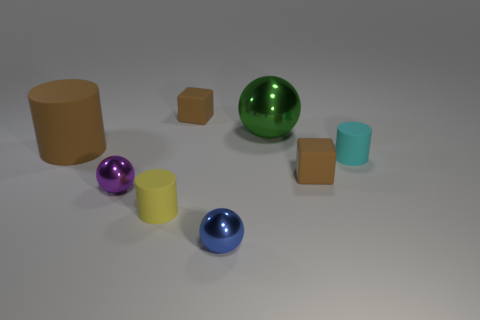Subtract all big green spheres. How many spheres are left? 2 Add 1 big blue shiny cylinders. How many objects exist? 9 Subtract 1 cylinders. How many cylinders are left? 2 Subtract all spheres. How many objects are left? 5 Subtract all brown balls. Subtract all brown cylinders. How many balls are left? 3 Subtract 0 red blocks. How many objects are left? 8 Subtract all tiny brown objects. Subtract all green metal balls. How many objects are left? 5 Add 8 brown matte cylinders. How many brown matte cylinders are left? 9 Add 4 large green metal spheres. How many large green metal spheres exist? 5 